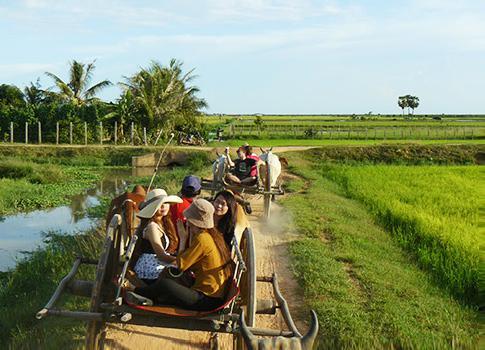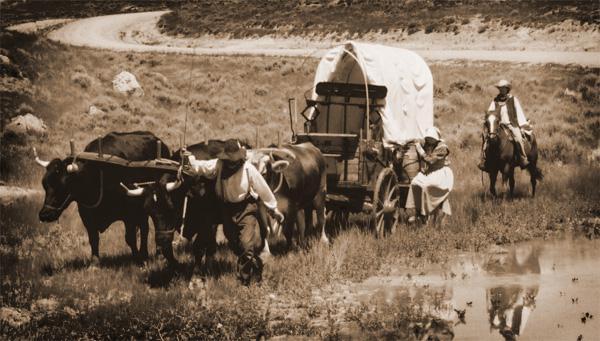The first image is the image on the left, the second image is the image on the right. Examine the images to the left and right. Is the description "In one image, two dark oxen pull a two-wheeled cart with two passengers and a driver in a cap leftward." accurate? Answer yes or no. No. The first image is the image on the left, the second image is the image on the right. Assess this claim about the two images: "there is only one person in one of the images.". Correct or not? Answer yes or no. No. 